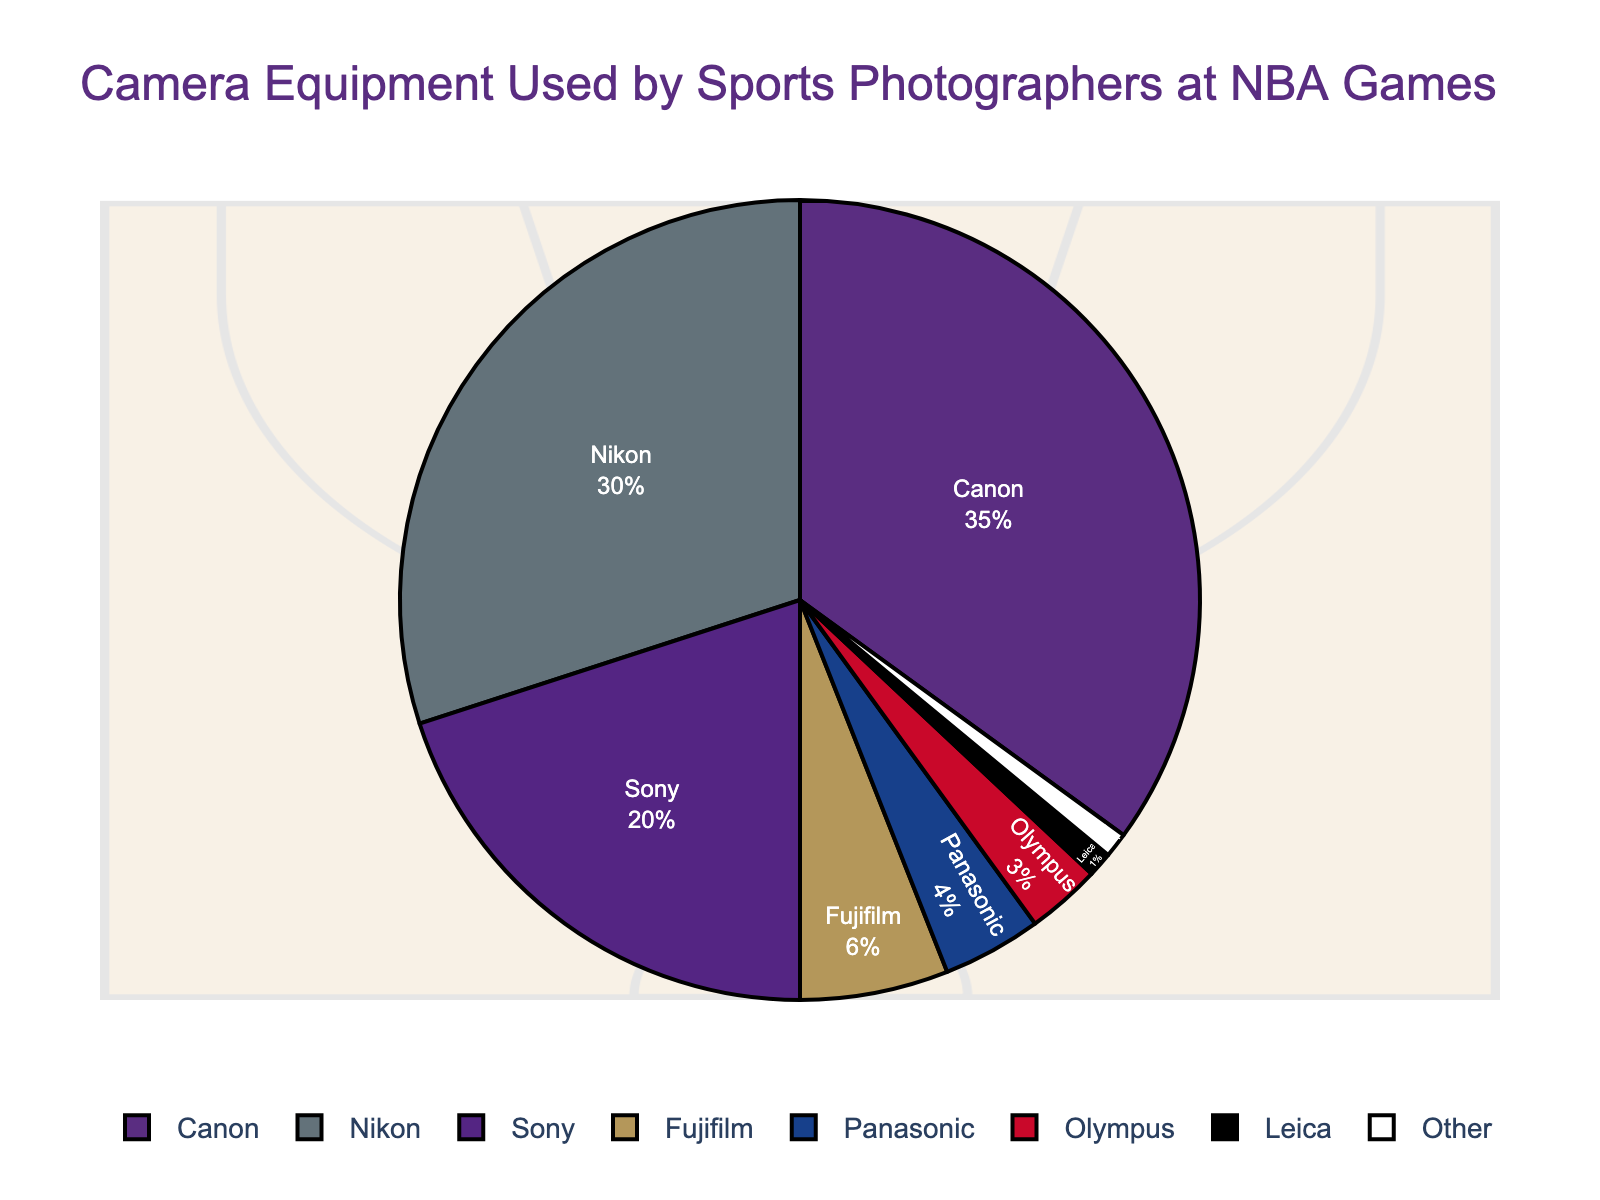What percentage of sports photographers use Nikon cameras? Referring to the pie chart, the segment labeled "Nikon" shows a percentage of 30%.
Answer: 30% Which camera brand is more popular among sports photographers at NBA games, Canon or Sony? By comparing the percentages, Canon has 35% while Sony has 20%. Therefore, Canon is more popular than Sony.
Answer: Canon What is the combined percentage of photographers using Fujifilm and Panasonic cameras? The chart shows 6% for Fujifilm and 4% for Panasonic. Adding these together, 6% + 4% = 10%.
Answer: 10% How many camera brands have a percentage lower than 5%? The pie chart shows Panasonic (4%), Olympus (3%), Leica (1%), and Other (1%). There are four camera brands with percentages less than 5%.
Answer: 4 Which camera brand segment is depicted in red, and what percentage does it represent? The segment depicted in red corresponds to Canon, which represents 35% as shown in the chart.
Answer: Canon, 35% Is the sum of percentages for Sony, Fujifilm, and Panasonic greater or smaller than that for Canon? The percentages for Sony, Fujifilm, and Panasonic are 20%, 6%, and 4%, respectively. Adding these gives: 20% + 6% + 4% = 30%. Canon alone has 35%. Therefore, the sum is smaller.
Answer: Smaller What is the difference in percentage between the most and least used camera brands? The most used is Canon with 35%, and the least used are Leica and Other with 1% each. The difference is 35% - 1% = 34%.
Answer: 34% Which camera brand shown in black on the pie chart, and what percentage of photographers use it? Observing the pie chart, the black color corresponds to Olympus, representing 3%.
Answer: Olympus, 3% What camera brand combination makes up 50% of the pie chart? Looking at the percentages, Canon (35%) and Nikon (30%) sum up to 65%. The closest combination below 50% is Nikon (30%) + Sony (20%) = 50%.
Answer: Nikon and Sony 